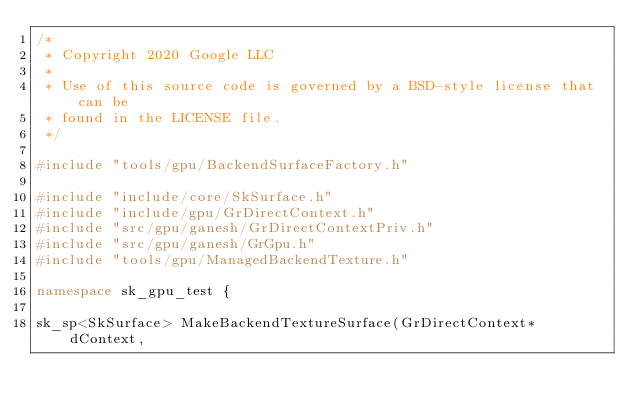Convert code to text. <code><loc_0><loc_0><loc_500><loc_500><_C++_>/*
 * Copyright 2020 Google LLC
 *
 * Use of this source code is governed by a BSD-style license that can be
 * found in the LICENSE file.
 */

#include "tools/gpu/BackendSurfaceFactory.h"

#include "include/core/SkSurface.h"
#include "include/gpu/GrDirectContext.h"
#include "src/gpu/ganesh/GrDirectContextPriv.h"
#include "src/gpu/ganesh/GrGpu.h"
#include "tools/gpu/ManagedBackendTexture.h"

namespace sk_gpu_test {

sk_sp<SkSurface> MakeBackendTextureSurface(GrDirectContext* dContext,</code> 